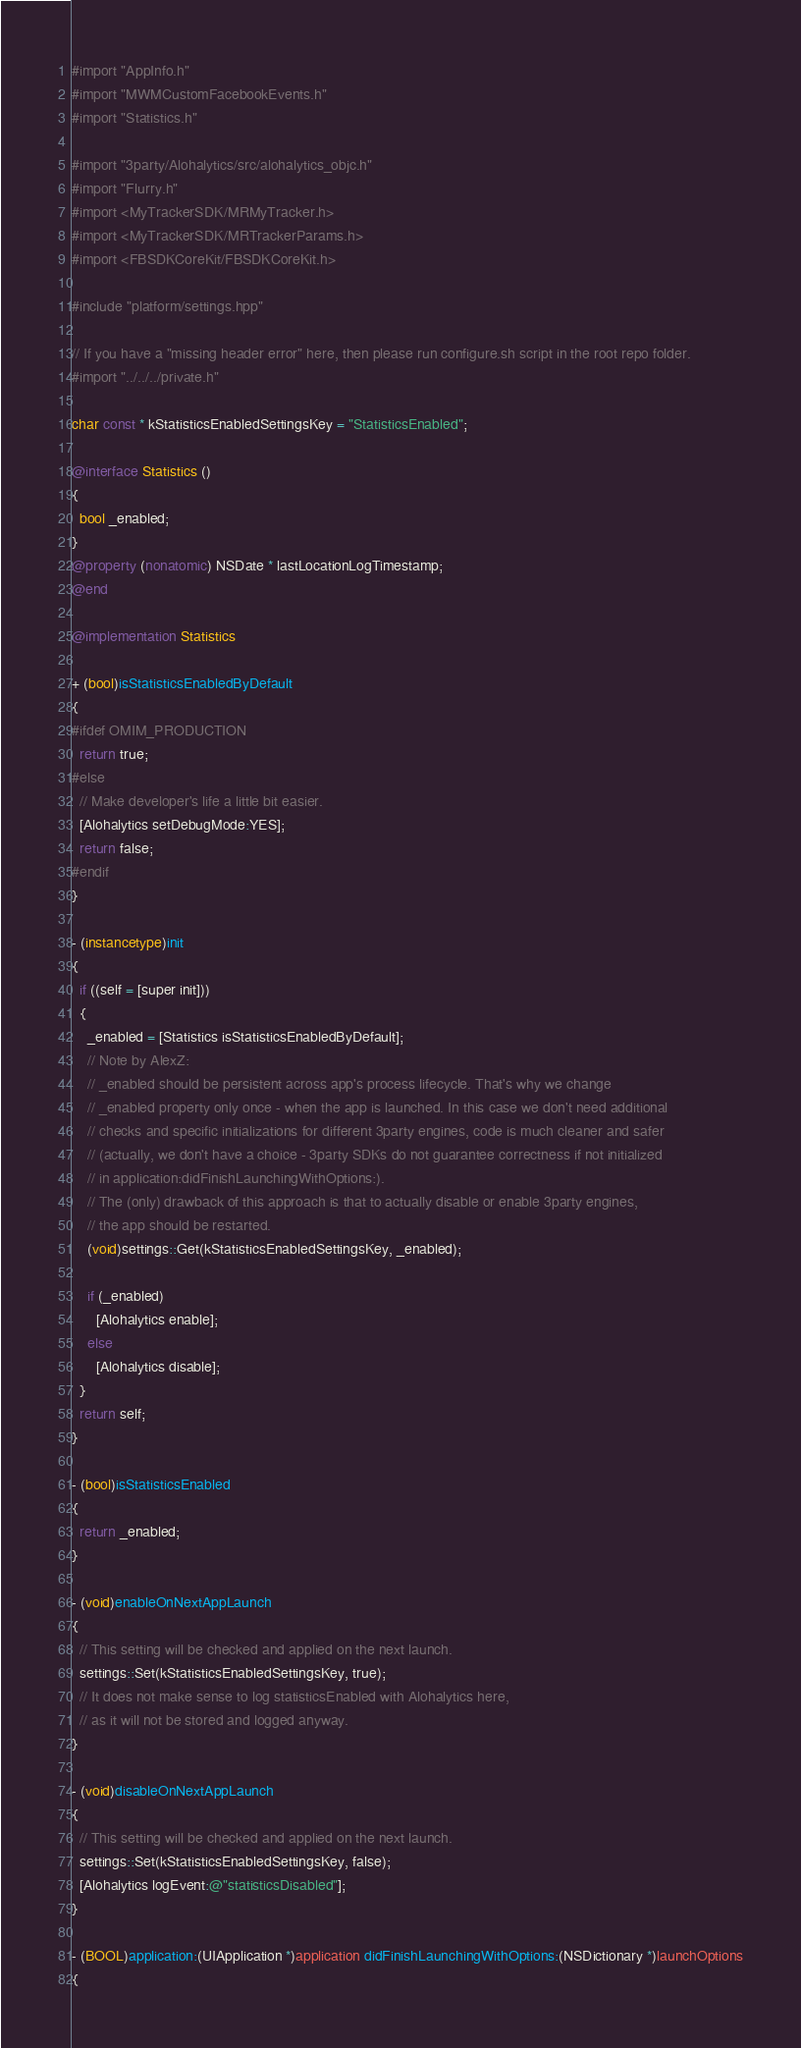<code> <loc_0><loc_0><loc_500><loc_500><_ObjectiveC_>#import "AppInfo.h"
#import "MWMCustomFacebookEvents.h"
#import "Statistics.h"

#import "3party/Alohalytics/src/alohalytics_objc.h"
#import "Flurry.h"
#import <MyTrackerSDK/MRMyTracker.h>
#import <MyTrackerSDK/MRTrackerParams.h>
#import <FBSDKCoreKit/FBSDKCoreKit.h>

#include "platform/settings.hpp"

// If you have a "missing header error" here, then please run configure.sh script in the root repo folder.
#import "../../../private.h"

char const * kStatisticsEnabledSettingsKey = "StatisticsEnabled";

@interface Statistics ()
{
  bool _enabled;
}
@property (nonatomic) NSDate * lastLocationLogTimestamp;
@end

@implementation Statistics

+ (bool)isStatisticsEnabledByDefault
{
#ifdef OMIM_PRODUCTION
  return true;
#else
  // Make developer's life a little bit easier.
  [Alohalytics setDebugMode:YES];
  return false;
#endif
}

- (instancetype)init
{
  if ((self = [super init]))
  {
    _enabled = [Statistics isStatisticsEnabledByDefault];
    // Note by AlexZ:
    // _enabled should be persistent across app's process lifecycle. That's why we change
    // _enabled property only once - when the app is launched. In this case we don't need additional
    // checks and specific initializations for different 3party engines, code is much cleaner and safer
    // (actually, we don't have a choice - 3party SDKs do not guarantee correctness if not initialized
    // in application:didFinishLaunchingWithOptions:).
    // The (only) drawback of this approach is that to actually disable or enable 3party engines,
    // the app should be restarted.
    (void)settings::Get(kStatisticsEnabledSettingsKey, _enabled);

    if (_enabled)
      [Alohalytics enable];
    else
      [Alohalytics disable];
  }
  return self;
}

- (bool)isStatisticsEnabled
{
  return _enabled;
}

- (void)enableOnNextAppLaunch
{
  // This setting will be checked and applied on the next launch.
  settings::Set(kStatisticsEnabledSettingsKey, true);
  // It does not make sense to log statisticsEnabled with Alohalytics here,
  // as it will not be stored and logged anyway.
}

- (void)disableOnNextAppLaunch
{
  // This setting will be checked and applied on the next launch.
  settings::Set(kStatisticsEnabledSettingsKey, false);
  [Alohalytics logEvent:@"statisticsDisabled"];
}

- (BOOL)application:(UIApplication *)application didFinishLaunchingWithOptions:(NSDictionary *)launchOptions
{</code> 